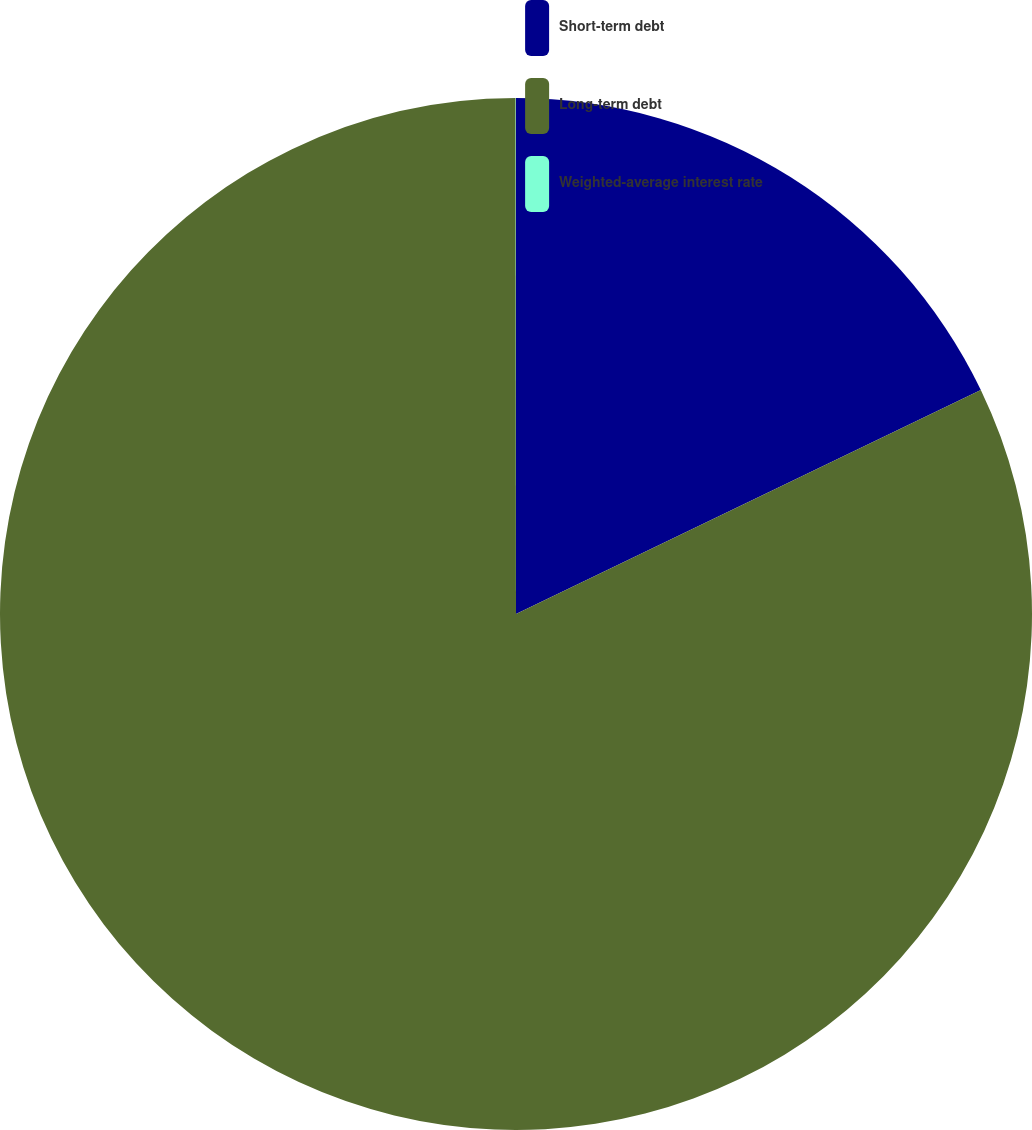Convert chart. <chart><loc_0><loc_0><loc_500><loc_500><pie_chart><fcel>Short-term debt<fcel>Long-term debt<fcel>Weighted-average interest rate<nl><fcel>17.85%<fcel>82.13%<fcel>0.01%<nl></chart> 